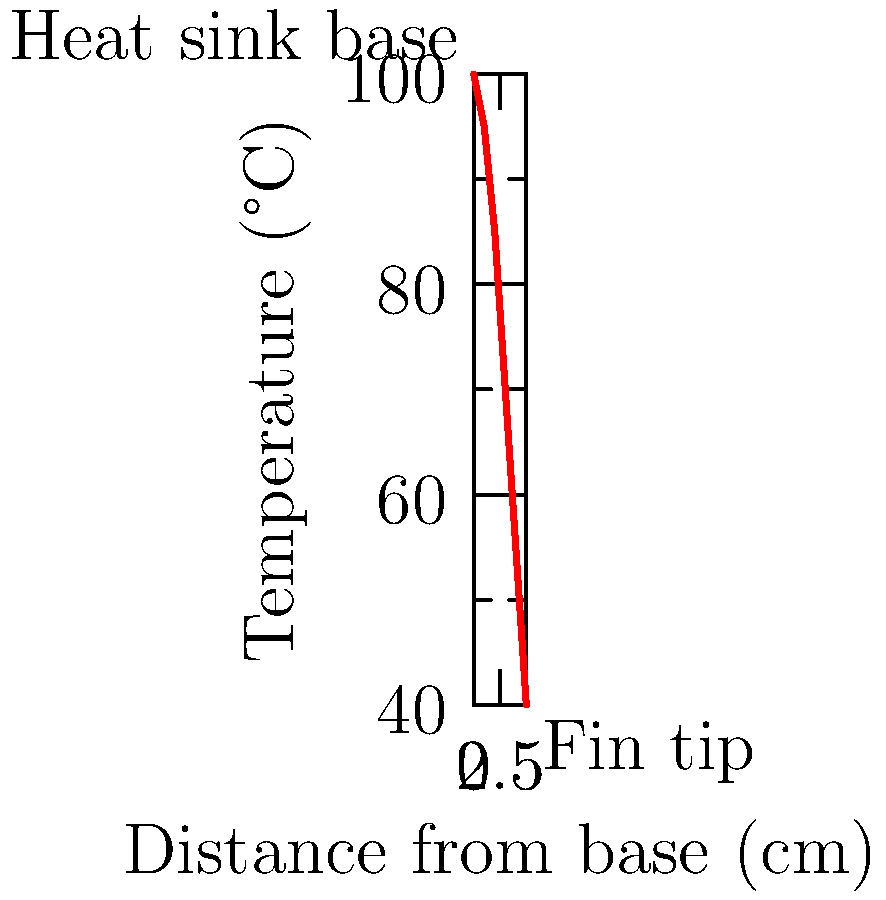In a reality TV show about innovative product design, contestants are challenged to create an efficient heat sink for a new smartphone. The graph shows the temperature distribution along a fin in their proposed heat sink design. If the marketing team wants to highlight the cooling efficiency, what percentage temperature reduction does the fin achieve from base to tip? To calculate the percentage temperature reduction from the base to the tip of the fin, we'll follow these steps:

1. Identify the temperature at the base (x = 0 cm):
   Base temperature = 100°C

2. Identify the temperature at the tip (x = 5 cm):
   Tip temperature = 40°C

3. Calculate the temperature difference:
   Temperature difference = Base temperature - Tip temperature
   Temperature difference = 100°C - 40°C = 60°C

4. Calculate the percentage reduction:
   Percentage reduction = (Temperature difference / Base temperature) × 100
   Percentage reduction = (60°C / 100°C) × 100 = 60%

The fin achieves a 60% temperature reduction from base to tip, which demonstrates significant cooling efficiency for the heat sink design.
Answer: 60% 